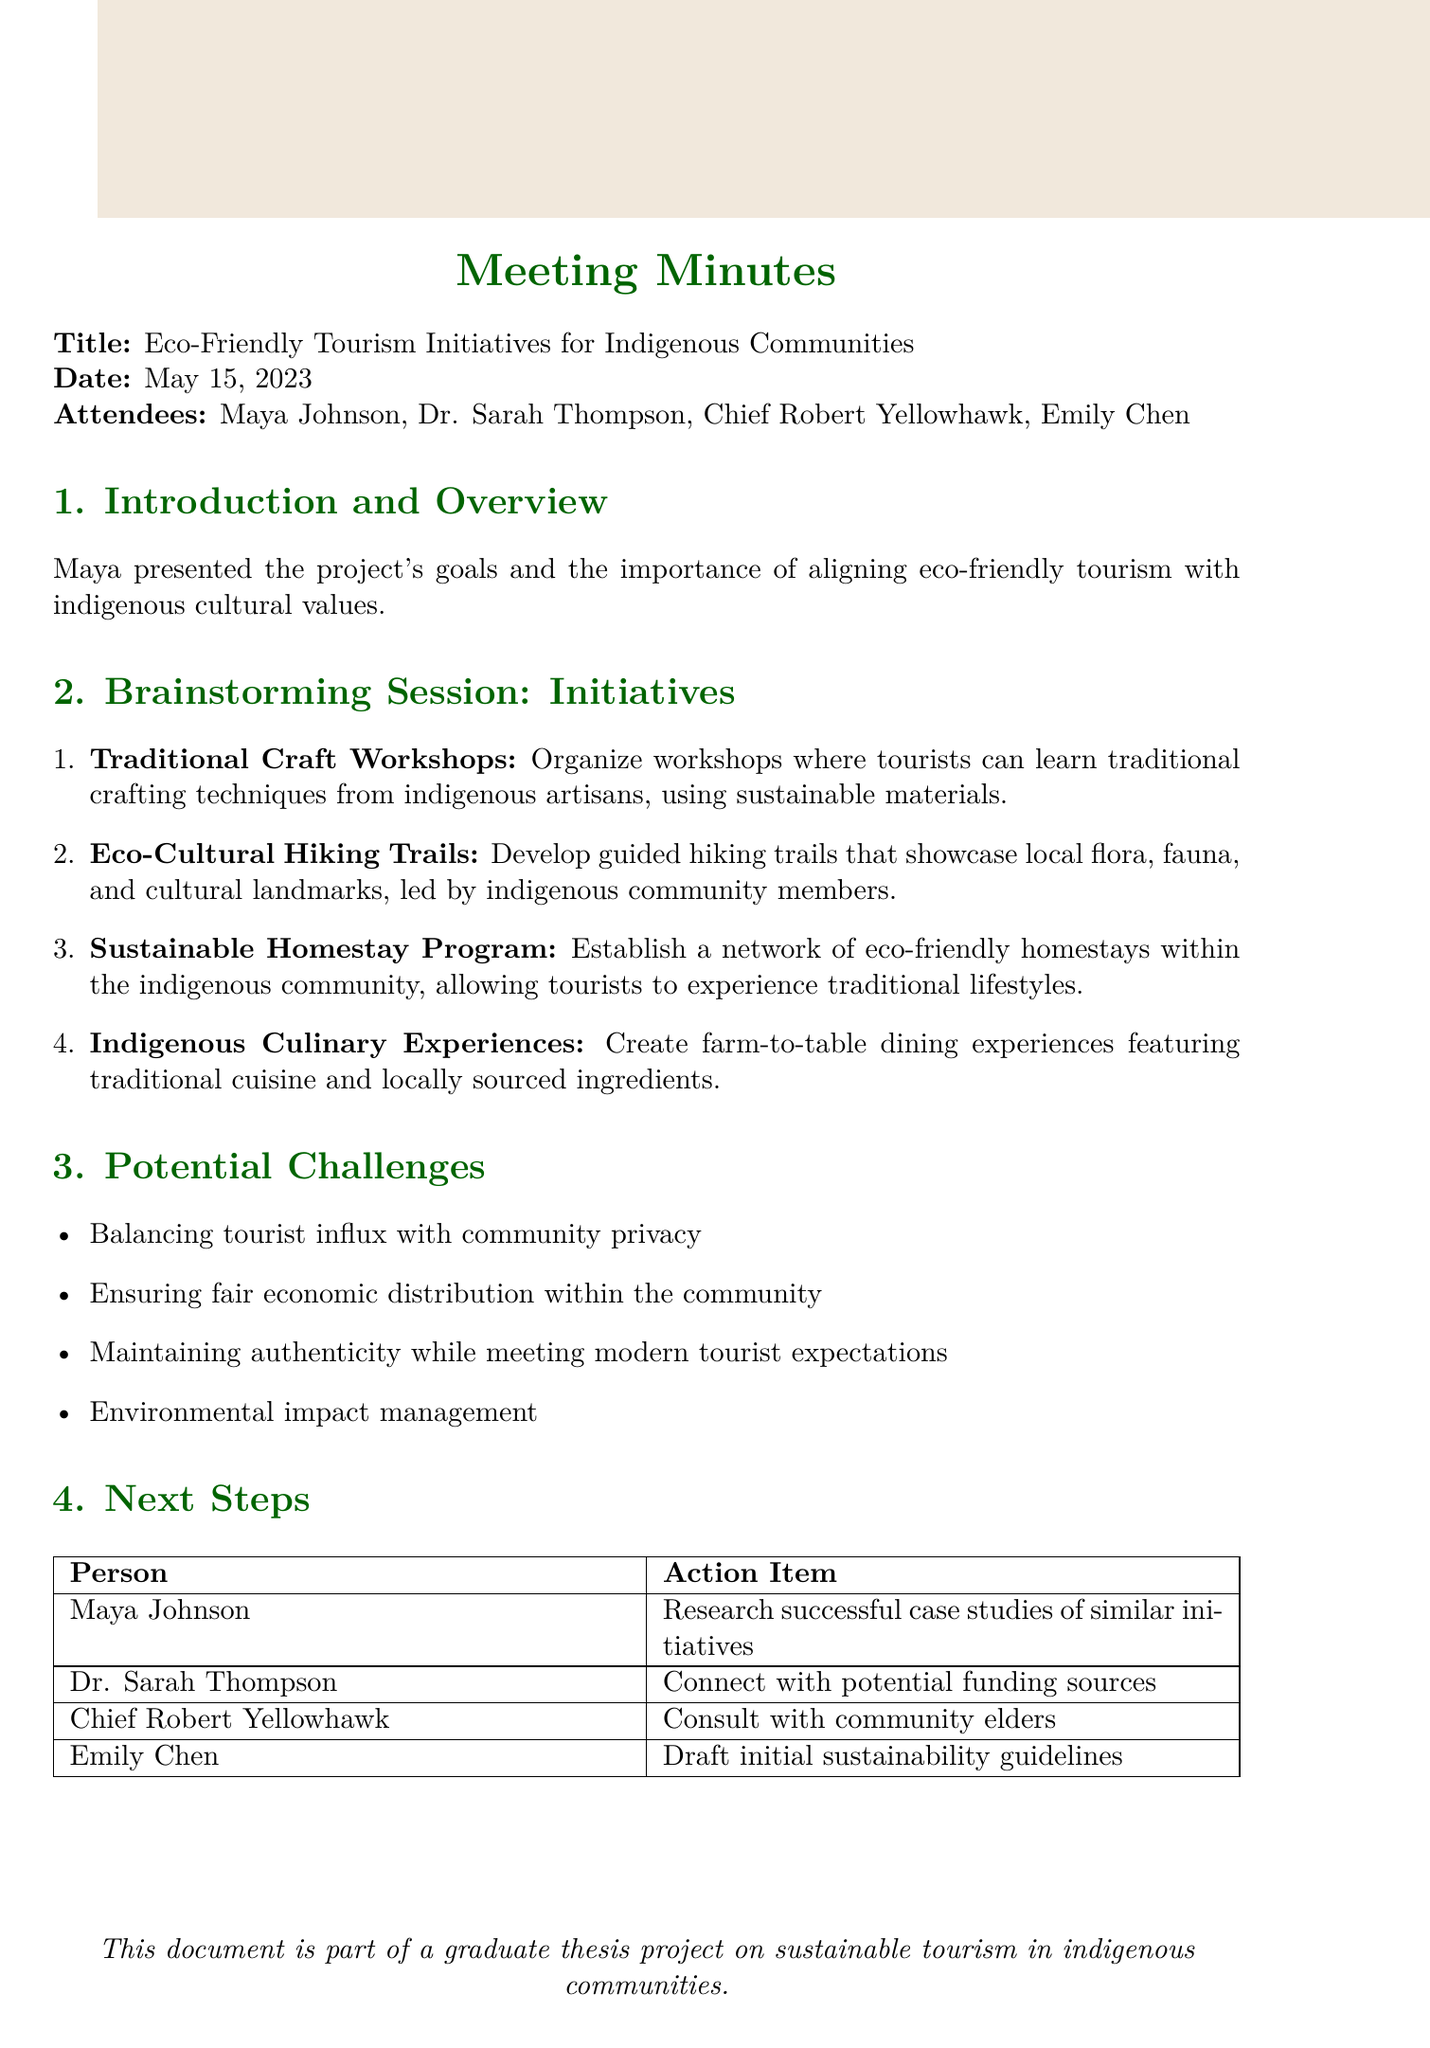what is the title of the meeting? The title of the meeting is stated at the top of the document.
Answer: Eco-Friendly Tourism Initiatives for Indigenous Communities who represented the indigenous community at the meeting? The document lists attendees and identifies the representative of the indigenous community.
Answer: Chief Robert Yellowhawk how many initiatives were brainstormed during the session? The document provides a list of initiatives discussed during the brainstorming session.
Answer: Four what is one potential challenge mentioned in the document? The document lists several challenges under the Potential Challenges section.
Answer: Balancing tourist influx with community privacy who will research successful case studies of similar initiatives? The Next Steps section specifies who is responsible for various action items, including this research task.
Answer: Maya Johnson what type of workshops were proposed? The initiatives section describes the nature of the workshops suggested during the meeting.
Answer: Traditional Craft Workshops what is one action item for Dr. Sarah Thompson? The document outlines specific actions assigned to each attendee in the Next Steps section.
Answer: Connect with potential funding sources what cooking experience was suggested in the initiatives? The proposed culinary experience is noted in the Brainstorming Session section of the document.
Answer: Indigenous Culinary Experiences 